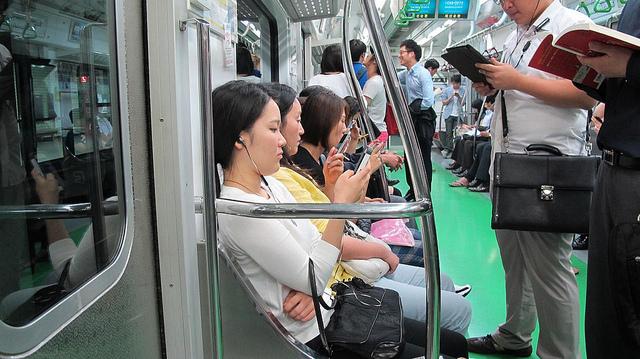Is this in a sailboat?
Short answer required. No. What is the lady thinking about nearest the camera?
Quick response, please. Music. What color is the floor?
Be succinct. Green. 